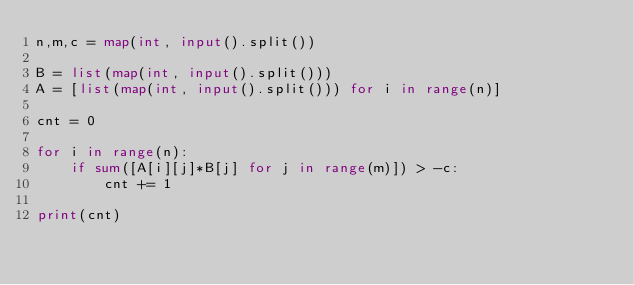Convert code to text. <code><loc_0><loc_0><loc_500><loc_500><_Python_>n,m,c = map(int, input().split())

B = list(map(int, input().split()))
A = [list(map(int, input().split())) for i in range(n)]

cnt = 0

for i in range(n):
    if sum([A[i][j]*B[j] for j in range(m)]) > -c:
        cnt += 1
        
print(cnt)</code> 